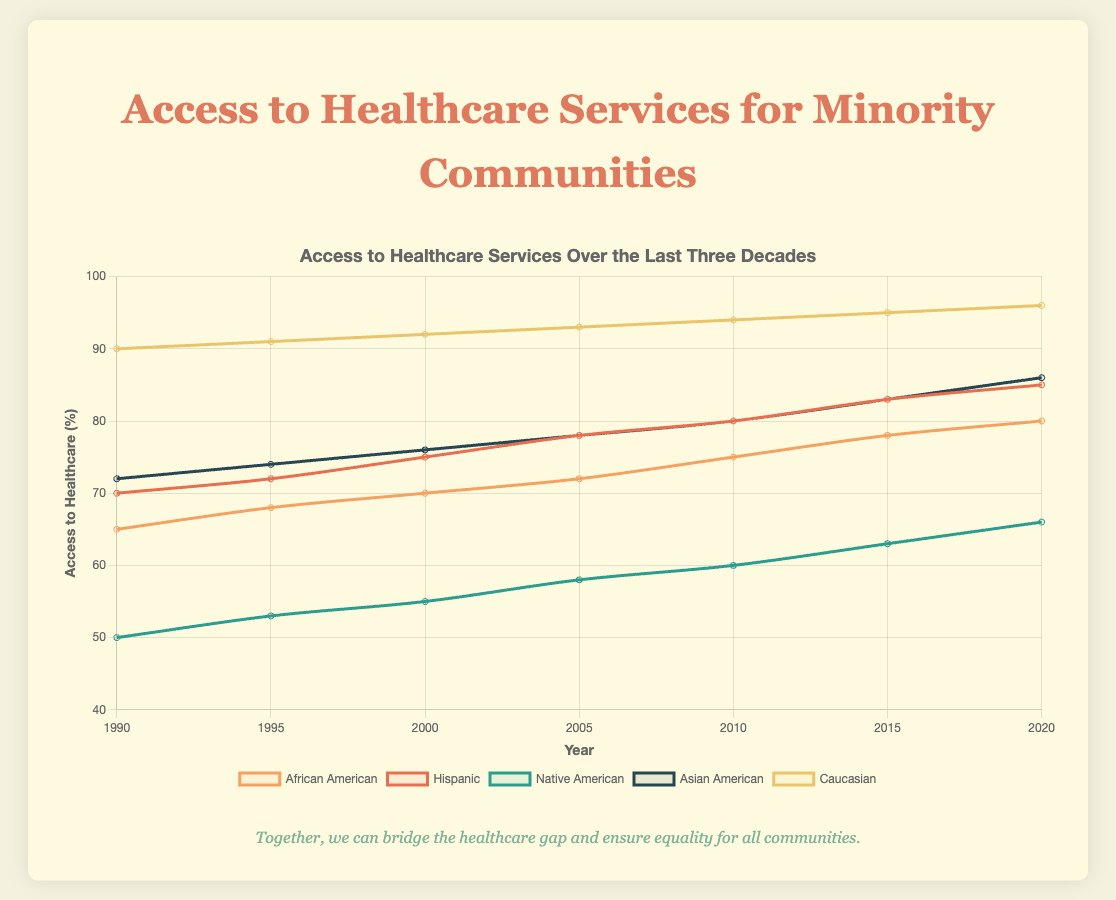Which minority community had the lowest access to healthcare in 1990? Looking at the plot for the year 1990, the line representing Native American access (green) is the lowest at 50%.
Answer: Native American How much did access to healthcare for Hispanic communities improve from 1990 to 2020? Subtract the value for Hispanic communities in 1990 (70%) from the value in 2020 (85%). The difference is 85% - 70% = 15%.
Answer: 15% Which community experienced the largest increase in access to healthcare from 1990 to 2020? Comparing the starting and ending points of each line: African American: 80% - 65% = 15%, Hispanic: 85% - 70% = 15%, Native American: 66% - 50% = 16%, Asian American: 86% - 72% = 14%, Caucasian: 96% - 90% = 6%. Native American has the highest increase (16%).
Answer: Native American In which year did African American communities first achieve 75% access to healthcare? Locate the 75% value on the y-axis and trace it horizontally to intersect the African American line (orange). The first intersection occurs in the year 2010.
Answer: 2010 How does the trend of access to healthcare for Asian American communities compare to African American communities over the decades? Observe and compare the slopes and patterns of the lines for Asian American (blue) and African American (orange). Both show consistent upward trends, but at slightly different rates, with Asian Americans starting higher and ending slightly higher than African Americans over all decades.
Answer: Consistent upward trends; Asian Americans higher What is the average access to healthcare for Caucasian communities across all the years shown? Sum the percentages for Caucasian communities from 1990 to 2020 (90 + 91 + 92 + 93 + 94 + 95 + 96 = 651), then divide by the number of years (651 / 7 ≈ 93).
Answer: 93 Describe the visual pattern of the curve representing Hispanic communities. The Hispanic community's curve (red) starts at 70% in 1990, shows a steady upward trend, reaching 85% by 2020. The line is smooth with no significant dips or spikes, indicating consistent improvement.
Answer: Steady upward trend, consistent improvement Which community has the smallest gap in healthcare access compared to Caucasian communities in 2020? In 2020, Caucasian access is at 96%. Compare the 2020 values for all other communities: African American (80%), Hispanic (85%), Native American (66%), Asian American (86%). The smallest gap is with Asian American (96% - 86% = 10%).
Answer: Asian American What are the three largest improvements in healthcare access from 1990 to 2000 among all communities? Calculate the differences for each community between 1990 and 2000: African American (70% - 65% = 5%), Hispanic (75% - 70% = 5%), Native American (55% - 50% = 5%), Asian American (76% - 72% = 4%), Caucasian (92% - 90% = 2%). The three largest improvements are African American, Hispanic, and Native American, all with 5%.
Answer: African American, Hispanic, Native American (5%) Between 2000 and 2020, which two communities saw the most similar patterns in their healthcare access trends? Examine the curves for the periods 2000 to 2020. African American (70% to 80%) and Asian American (76% to 86%) have both straight and similar upward trends with increments of 10%.
Answer: African American and Asian American 